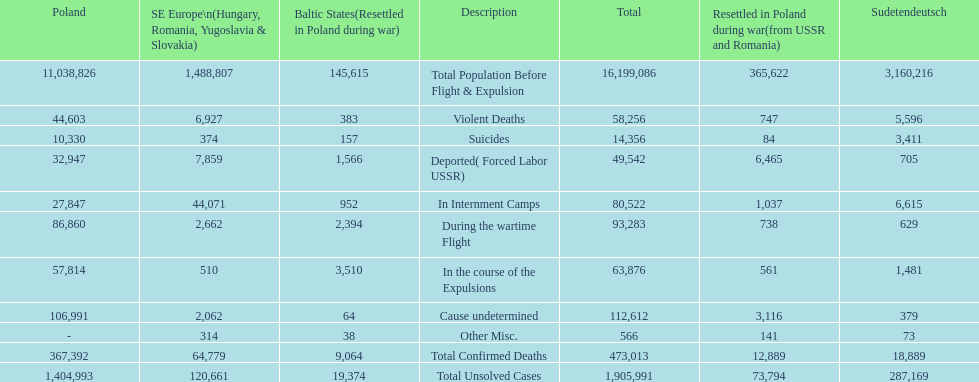Did any location have no violent deaths? No. 